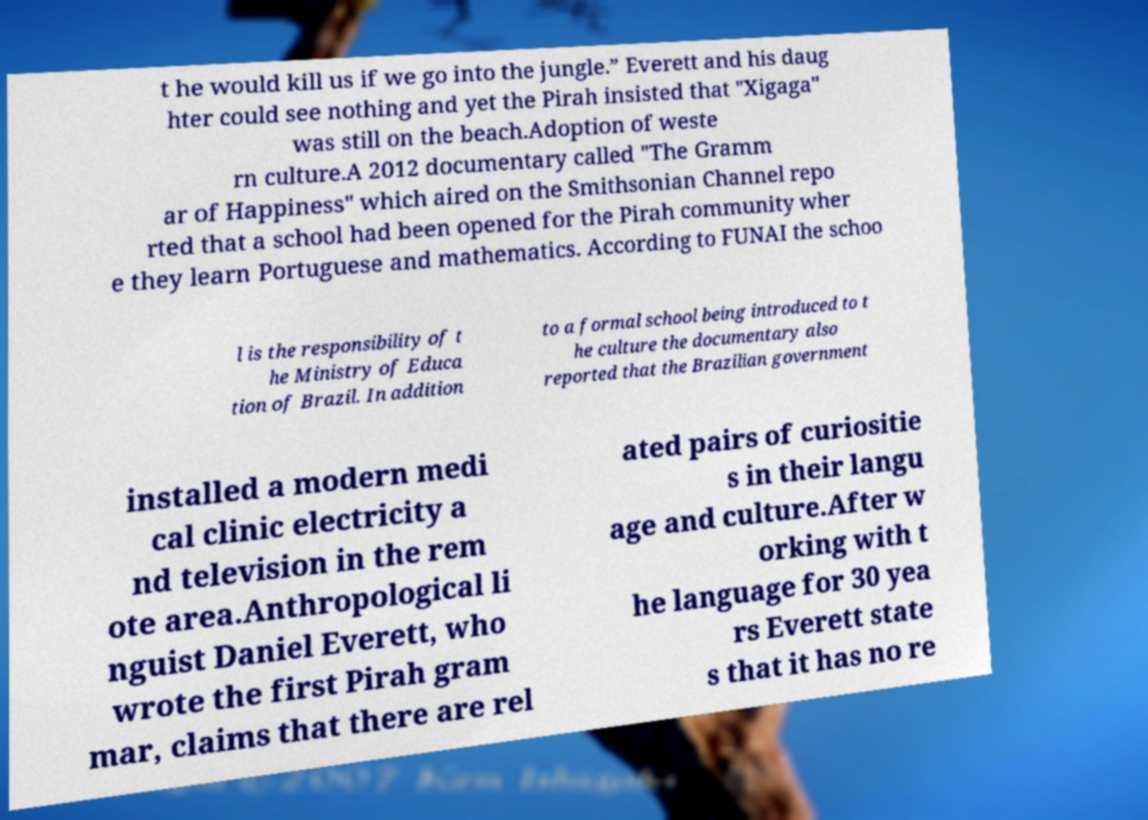Could you extract and type out the text from this image? t he would kill us if we go into the jungle.” Everett and his daug hter could see nothing and yet the Pirah insisted that "Xigaga" was still on the beach.Adoption of weste rn culture.A 2012 documentary called "The Gramm ar of Happiness" which aired on the Smithsonian Channel repo rted that a school had been opened for the Pirah community wher e they learn Portuguese and mathematics. According to FUNAI the schoo l is the responsibility of t he Ministry of Educa tion of Brazil. In addition to a formal school being introduced to t he culture the documentary also reported that the Brazilian government installed a modern medi cal clinic electricity a nd television in the rem ote area.Anthropological li nguist Daniel Everett, who wrote the first Pirah gram mar, claims that there are rel ated pairs of curiositie s in their langu age and culture.After w orking with t he language for 30 yea rs Everett state s that it has no re 